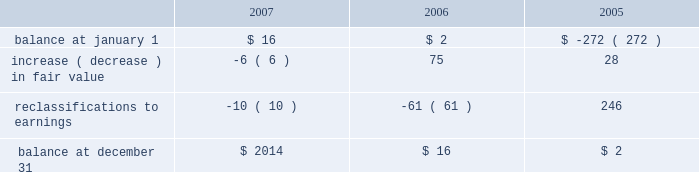The fair value of the interest agreements at december 31 , 2007 and december 31 , 2006 was $ 3 million and $ 1 million , respectively .
The company is exposed to credit loss in the event of nonperformance by the counterparties to its swap contracts .
The company minimizes its credit risk on these transactions by only dealing with leading , creditworthy financial institutions and does not anticipate nonperformance .
In addition , the contracts are distributed among several financial institutions , all of whom presently have investment grade credit ratings , thus minimizing credit risk concentration .
Stockholders 2019 equity derivative instruments activity , net of tax , included in non-owner changes to equity within the consolidated statements of stockholders 2019 equity for the years ended december 31 , 2007 and 2006 is as follows: .
Net investment in foreign operations hedge at december 31 , 2007 and 2006 , the company did not have any hedges of foreign currency exposure of net investments in foreign operations .
Investments hedge during the first quarter of 2006 , the company entered into a zero-cost collar derivative ( the 201csprint nextel derivative 201d ) to protect itself economically against price fluctuations in its 37.6 million shares of sprint nextel corporation ( 201csprint nextel 201d ) non-voting common stock .
During the second quarter of 2006 , as a result of sprint nextel 2019s spin-off of embarq corporation through a dividend to sprint nextel shareholders , the company received approximately 1.9 million shares of embarq corporation .
The floor and ceiling prices of the sprint nextel derivative were adjusted accordingly .
The sprint nextel derivative was not designated as a hedge under the provisions of sfas no .
133 , 201caccounting for derivative instruments and hedging activities . 201d accordingly , to reflect the change in fair value of the sprint nextel derivative , the company recorded a net gain of $ 99 million for the year ended december 31 , 2006 , included in other income ( expense ) in the company 2019s consolidated statements of operations .
In december 2006 , the sprint nextel derivative was terminated and settled in cash and the 37.6 million shares of sprint nextel were converted to common shares and sold .
The company received aggregate cash proceeds of approximately $ 820 million from the settlement of the sprint nextel derivative and the subsequent sale of the 37.6 million sprint nextel shares .
The company recognized a loss of $ 126 million in connection with the sale of the remaining shares of sprint nextel common stock .
As described above , the company recorded a net gain of $ 99 million in connection with the sprint nextel derivative .
Prior to the merger of sprint corporation ( 201csprint 201d ) and nextel communications , inc .
( 201cnextel 201d ) , the company had entered into variable share forward purchase agreements ( the 201cvariable forwards 201d ) to hedge its nextel common stock .
The company did not designate the variable forwards as a hedge of the sprint nextel shares received as a result of the merger .
Accordingly , the company recorded $ 51 million of gains for the year ended december 31 , 2005 reflecting the change in value of the variable forwards .
The variable forwards were settled during the fourth quarter of 2005 .
Fair value of financial instruments the company 2019s financial instruments include cash equivalents , sigma fund investments , short-term investments , accounts receivable , long-term finance receivables , accounts payable , accrued liabilities , derivatives and other financing commitments .
The company 2019s sigma fund and investment portfolios and derivatives are recorded in the company 2019s consolidated balance sheets at fair value .
All other financial instruments , with the exception of long-term debt , are carried at cost , which is not materially different than the instruments 2019 fair values. .
What is the percent change in stockholders 2019 equity derivative between january and december 2006? 
Computations: ((16 - 2) / 2)
Answer: 7.0. 